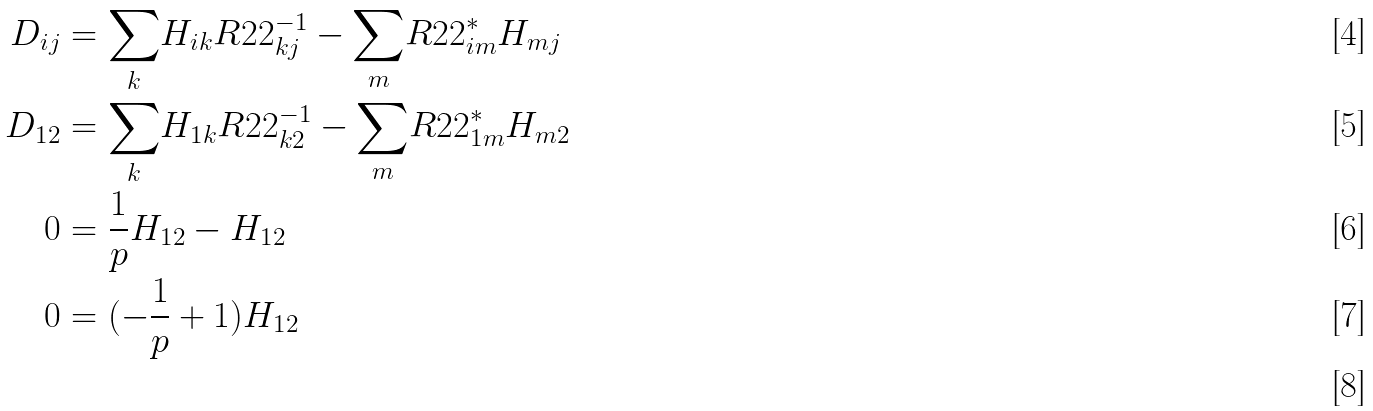Convert formula to latex. <formula><loc_0><loc_0><loc_500><loc_500>D _ { i j } & = \underset { k } { \sum } H _ { i k } R 2 2 ^ { - 1 } _ { k j } - \underset { m } { \sum } R 2 2 ^ { * } _ { i m } H _ { m j } \\ D _ { 1 2 } & = \underset { k } { \sum } H _ { 1 k } R 2 2 ^ { - 1 } _ { k 2 } - \underset { m } { \sum } R 2 2 ^ { * } _ { 1 m } H _ { m 2 } \\ 0 & = \frac { 1 } { p } H _ { 1 2 } - H _ { 1 2 } \\ 0 & = ( - \frac { 1 } { p } + 1 ) H _ { 1 2 } \\</formula> 